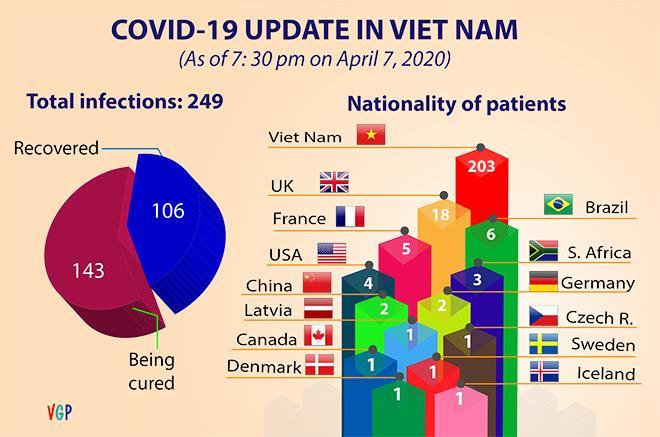Which country has the highest number of patients in Vietnam?
Answer the question with a short phrase. Vietnam How many countries have patients =1 in Vietnam? 6 Which one has the highest share- recovered, or being cured? being cured 